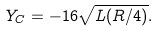Convert formula to latex. <formula><loc_0><loc_0><loc_500><loc_500>Y _ { C } = - 1 6 \sqrt { L ( R / 4 ) } .</formula> 